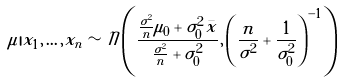<formula> <loc_0><loc_0><loc_500><loc_500>\mu | x _ { 1 } , \dots , x _ { n } \sim { \mathcal { N } } \left ( { \frac { { \frac { \sigma ^ { 2 } } { n } } \mu _ { 0 } + \sigma _ { 0 } ^ { 2 } { \bar { x } } } { { \frac { \sigma ^ { 2 } } { n } } + \sigma _ { 0 } ^ { 2 } } } , \left ( { \frac { n } { \sigma ^ { 2 } } } + { \frac { 1 } { \sigma _ { 0 } ^ { 2 } } } \right ) ^ { - 1 } \right )</formula> 